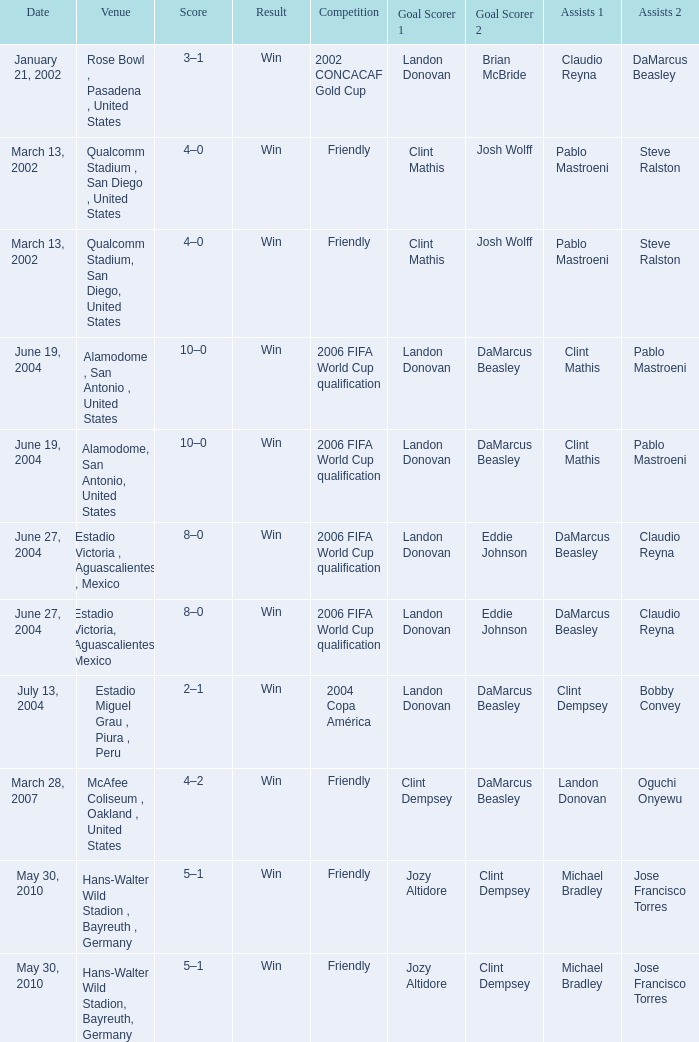What competition has June 19, 2004 as the date? 2006 FIFA World Cup qualification, 2006 FIFA World Cup qualification. 